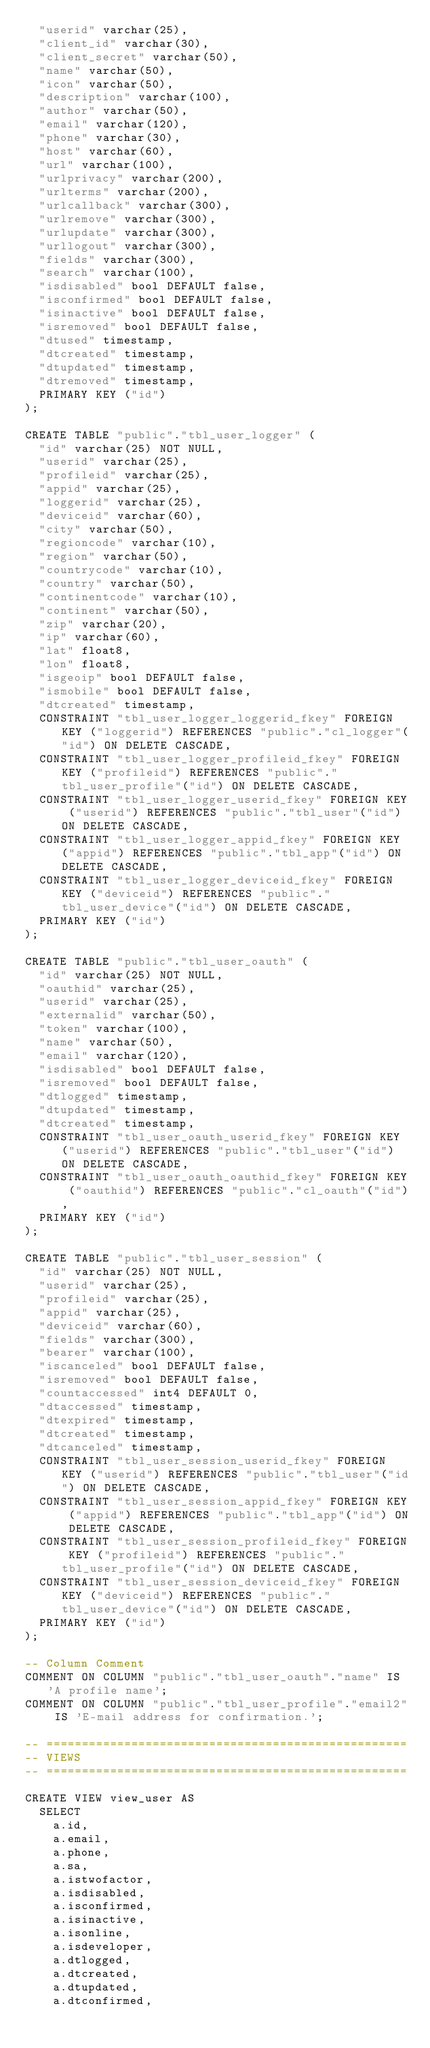<code> <loc_0><loc_0><loc_500><loc_500><_SQL_>	"userid" varchar(25),
	"client_id" varchar(30),
	"client_secret" varchar(50),
	"name" varchar(50),
	"icon" varchar(50),
	"description" varchar(100),
	"author" varchar(50),
	"email" varchar(120),
	"phone" varchar(30),
	"host" varchar(60),
	"url" varchar(100),
	"urlprivacy" varchar(200),
	"urlterms" varchar(200),
	"urlcallback" varchar(300),
	"urlremove" varchar(300),
	"urlupdate" varchar(300),
	"urllogout" varchar(300),
	"fields" varchar(300),
	"search" varchar(100),
	"isdisabled" bool DEFAULT false,
	"isconfirmed" bool DEFAULT false,
	"isinactive" bool DEFAULT false,
	"isremoved" bool DEFAULT false,
	"dtused" timestamp,
	"dtcreated" timestamp,
	"dtupdated" timestamp,
	"dtremoved" timestamp,
	PRIMARY KEY ("id")
);

CREATE TABLE "public"."tbl_user_logger" (
	"id" varchar(25) NOT NULL,
	"userid" varchar(25),
	"profileid" varchar(25),
	"appid" varchar(25),
	"loggerid" varchar(25),
	"deviceid" varchar(60),
	"city" varchar(50),
	"regioncode" varchar(10),
	"region" varchar(50),
	"countrycode" varchar(10),
	"country" varchar(50),
	"continentcode" varchar(10),
	"continent" varchar(50),
	"zip" varchar(20),
	"ip" varchar(60),
	"lat" float8,
	"lon" float8,
	"isgeoip" bool DEFAULT false,
	"ismobile" bool DEFAULT false,
	"dtcreated" timestamp,
	CONSTRAINT "tbl_user_logger_loggerid_fkey" FOREIGN KEY ("loggerid") REFERENCES "public"."cl_logger"("id") ON DELETE CASCADE,
	CONSTRAINT "tbl_user_logger_profileid_fkey" FOREIGN KEY ("profileid") REFERENCES "public"."tbl_user_profile"("id") ON DELETE CASCADE,
	CONSTRAINT "tbl_user_logger_userid_fkey" FOREIGN KEY ("userid") REFERENCES "public"."tbl_user"("id") ON DELETE CASCADE,
	CONSTRAINT "tbl_user_logger_appid_fkey" FOREIGN KEY ("appid") REFERENCES "public"."tbl_app"("id") ON DELETE CASCADE,
	CONSTRAINT "tbl_user_logger_deviceid_fkey" FOREIGN KEY ("deviceid") REFERENCES "public"."tbl_user_device"("id") ON DELETE CASCADE,
	PRIMARY KEY ("id")
);

CREATE TABLE "public"."tbl_user_oauth" (
	"id" varchar(25) NOT NULL,
	"oauthid" varchar(25),
	"userid" varchar(25),
	"externalid" varchar(50),
	"token" varchar(100),
	"name" varchar(50),
	"email" varchar(120),
	"isdisabled" bool DEFAULT false,
	"isremoved" bool DEFAULT false,
	"dtlogged" timestamp,
	"dtupdated" timestamp,
	"dtcreated" timestamp,
	CONSTRAINT "tbl_user_oauth_userid_fkey" FOREIGN KEY ("userid") REFERENCES "public"."tbl_user"("id") ON DELETE CASCADE,
	CONSTRAINT "tbl_user_oauth_oauthid_fkey" FOREIGN KEY ("oauthid") REFERENCES "public"."cl_oauth"("id"),
	PRIMARY KEY ("id")
);

CREATE TABLE "public"."tbl_user_session" (
	"id" varchar(25) NOT NULL,
	"userid" varchar(25),
	"profileid" varchar(25),
	"appid" varchar(25),
	"deviceid" varchar(60),
	"fields" varchar(300),
	"bearer" varchar(100),
	"iscanceled" bool DEFAULT false,
	"isremoved" bool DEFAULT false,
	"countaccessed" int4 DEFAULT 0,
	"dtaccessed" timestamp,
	"dtexpired" timestamp,
	"dtcreated" timestamp,
	"dtcanceled" timestamp,
	CONSTRAINT "tbl_user_session_userid_fkey" FOREIGN KEY ("userid") REFERENCES "public"."tbl_user"("id") ON DELETE CASCADE,
	CONSTRAINT "tbl_user_session_appid_fkey" FOREIGN KEY ("appid") REFERENCES "public"."tbl_app"("id") ON DELETE CASCADE,
	CONSTRAINT "tbl_user_session_profileid_fkey" FOREIGN KEY ("profileid") REFERENCES "public"."tbl_user_profile"("id") ON DELETE CASCADE,
	CONSTRAINT "tbl_user_session_deviceid_fkey" FOREIGN KEY ("deviceid") REFERENCES "public"."tbl_user_device"("id") ON DELETE CASCADE,
	PRIMARY KEY ("id")
);

-- Column Comment
COMMENT ON COLUMN "public"."tbl_user_oauth"."name" IS 'A profile name';
COMMENT ON COLUMN "public"."tbl_user_profile"."email2" IS 'E-mail address for confirmation.';

-- ===================================================
-- VIEWS
-- ===================================================

CREATE VIEW view_user AS
	SELECT
		a.id,
		a.email,
		a.phone,
		a.sa,
		a.istwofactor,
		a.isdisabled,
		a.isconfirmed,
		a.isinactive,
		a.isonline,
		a.isdeveloper,
		a.dtlogged,
		a.dtcreated,
		a.dtupdated,
		a.dtconfirmed,</code> 